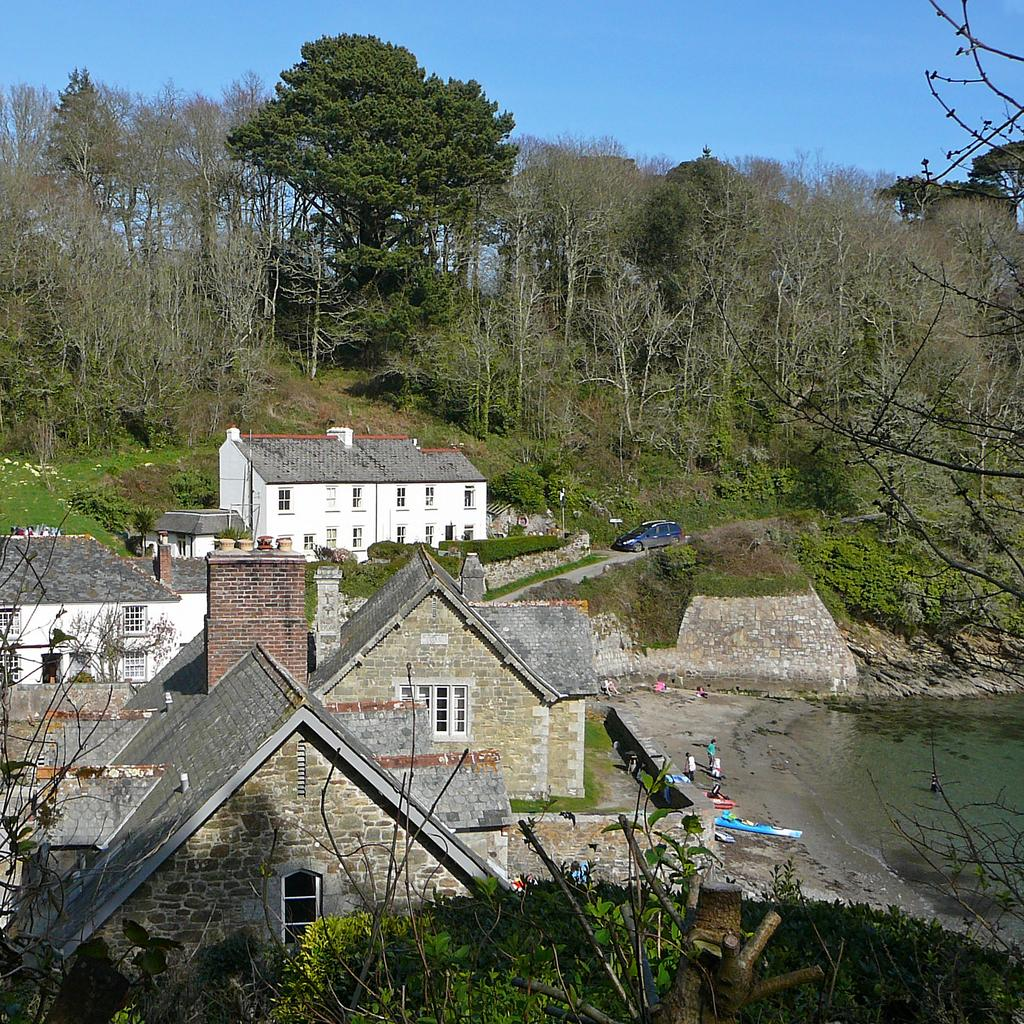What is the location of the persons in the image? The persons are standing on the seashore. What can be seen in the image besides the persons? There is water, buildings, trees, a motor vehicle on the road, hills, and the sky visible in the image. Can you describe the natural features in the image? The natural features in the image include water, trees, and hills. What type of road transportation is visible in the image? There is a motor vehicle on the road in the image. What type of toys are the persons playing with on the seashore? There are no toys visible in the image; the persons are standing on the seashore. What knowledge can be gained from the image about hobbies? The image does not provide any information about the hobbies of the persons or the people who created the image. 